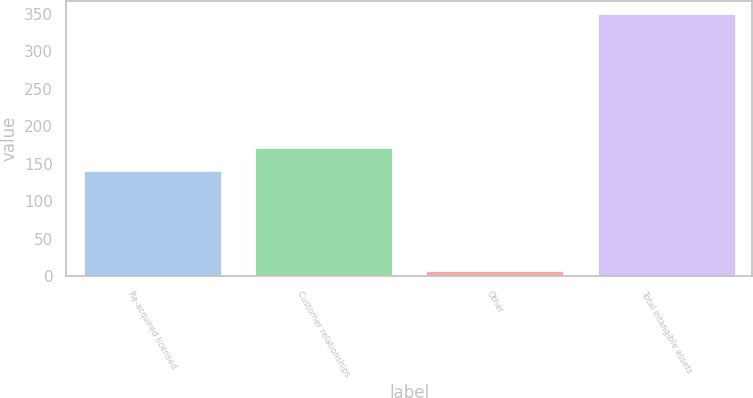<chart> <loc_0><loc_0><loc_500><loc_500><bar_chart><fcel>Re-acquired licensed<fcel>Customer relationships<fcel>Other<fcel>Total intangible assets<nl><fcel>140<fcel>171.4<fcel>7.2<fcel>349.74<nl></chart> 